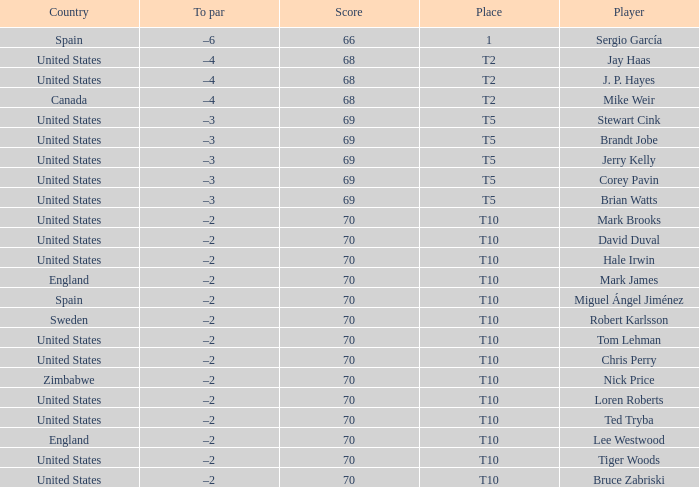Which player had a score of 70? Mark Brooks, David Duval, Hale Irwin, Mark James, Miguel Ángel Jiménez, Robert Karlsson, Tom Lehman, Chris Perry, Nick Price, Loren Roberts, Ted Tryba, Lee Westwood, Tiger Woods, Bruce Zabriski. 